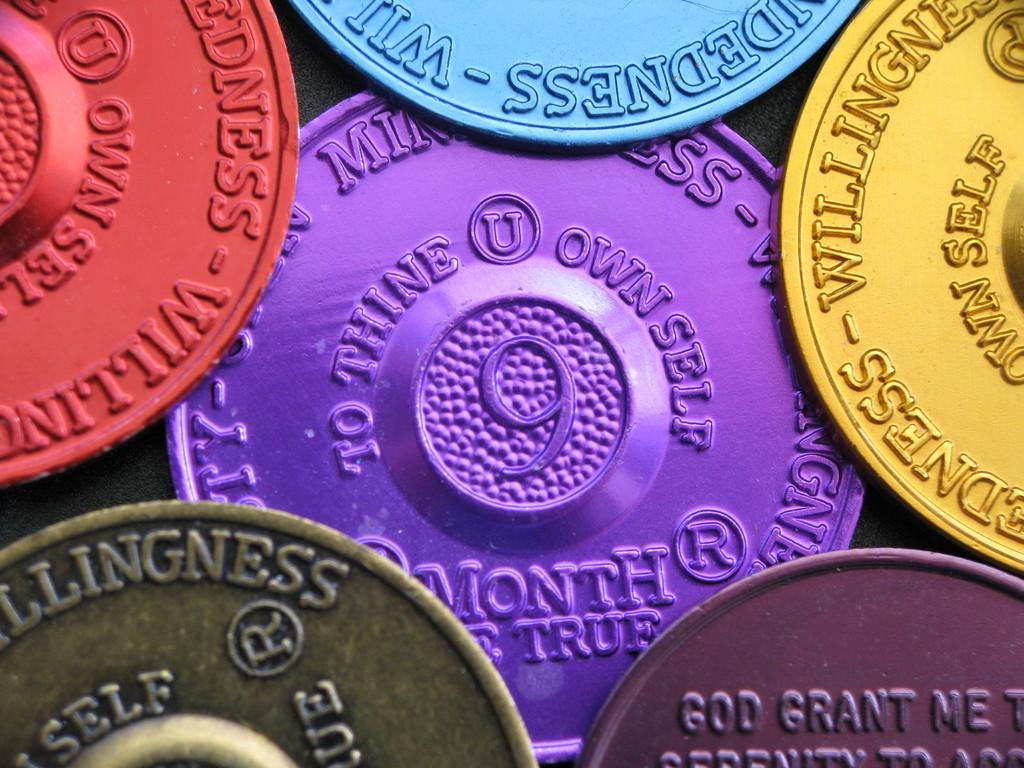<image>
Relay a brief, clear account of the picture shown. several colored coins that all have willingness on them 